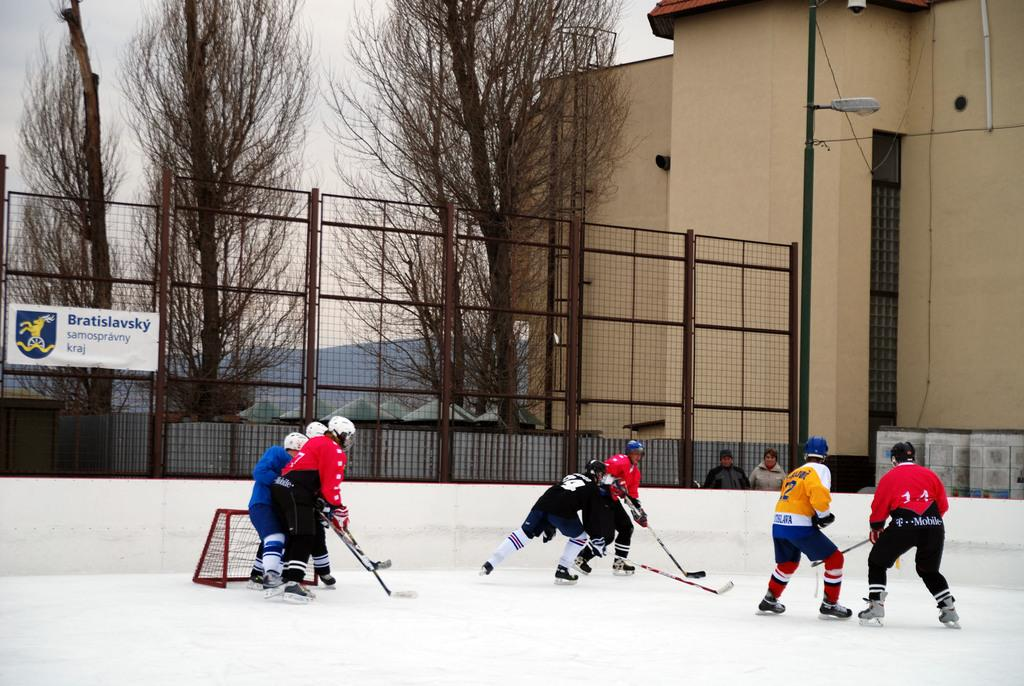What activity are the persons in the image engaged in? The persons in the image are playing ice hockey. What can be seen in the background of the image? There is sky, trees, buildings, a street light, a name board, and fences visible in the background of the image. What type of scarf is being used as a prop in the ice hockey game? There is no scarf present in the image, and no scarf is being used as a prop in the ice hockey game. 